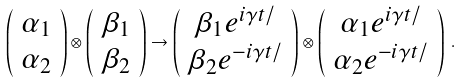<formula> <loc_0><loc_0><loc_500><loc_500>\left ( \begin{array} { c } \alpha _ { 1 } \\ \alpha _ { 2 } \end{array} \right ) \otimes \left ( \begin{array} { c } \beta _ { 1 } \\ \beta _ { 2 } \end{array} \right ) \rightarrow \left ( \begin{array} { c } \beta _ { 1 } e ^ { i \gamma t / } \\ \beta _ { 2 } e ^ { - i \gamma t / } \end{array} \right ) \otimes \left ( \begin{array} { c } \alpha _ { 1 } e ^ { i \gamma t / } \\ \alpha _ { 2 } e ^ { - i \gamma t / } \end{array} \right ) \, .</formula> 